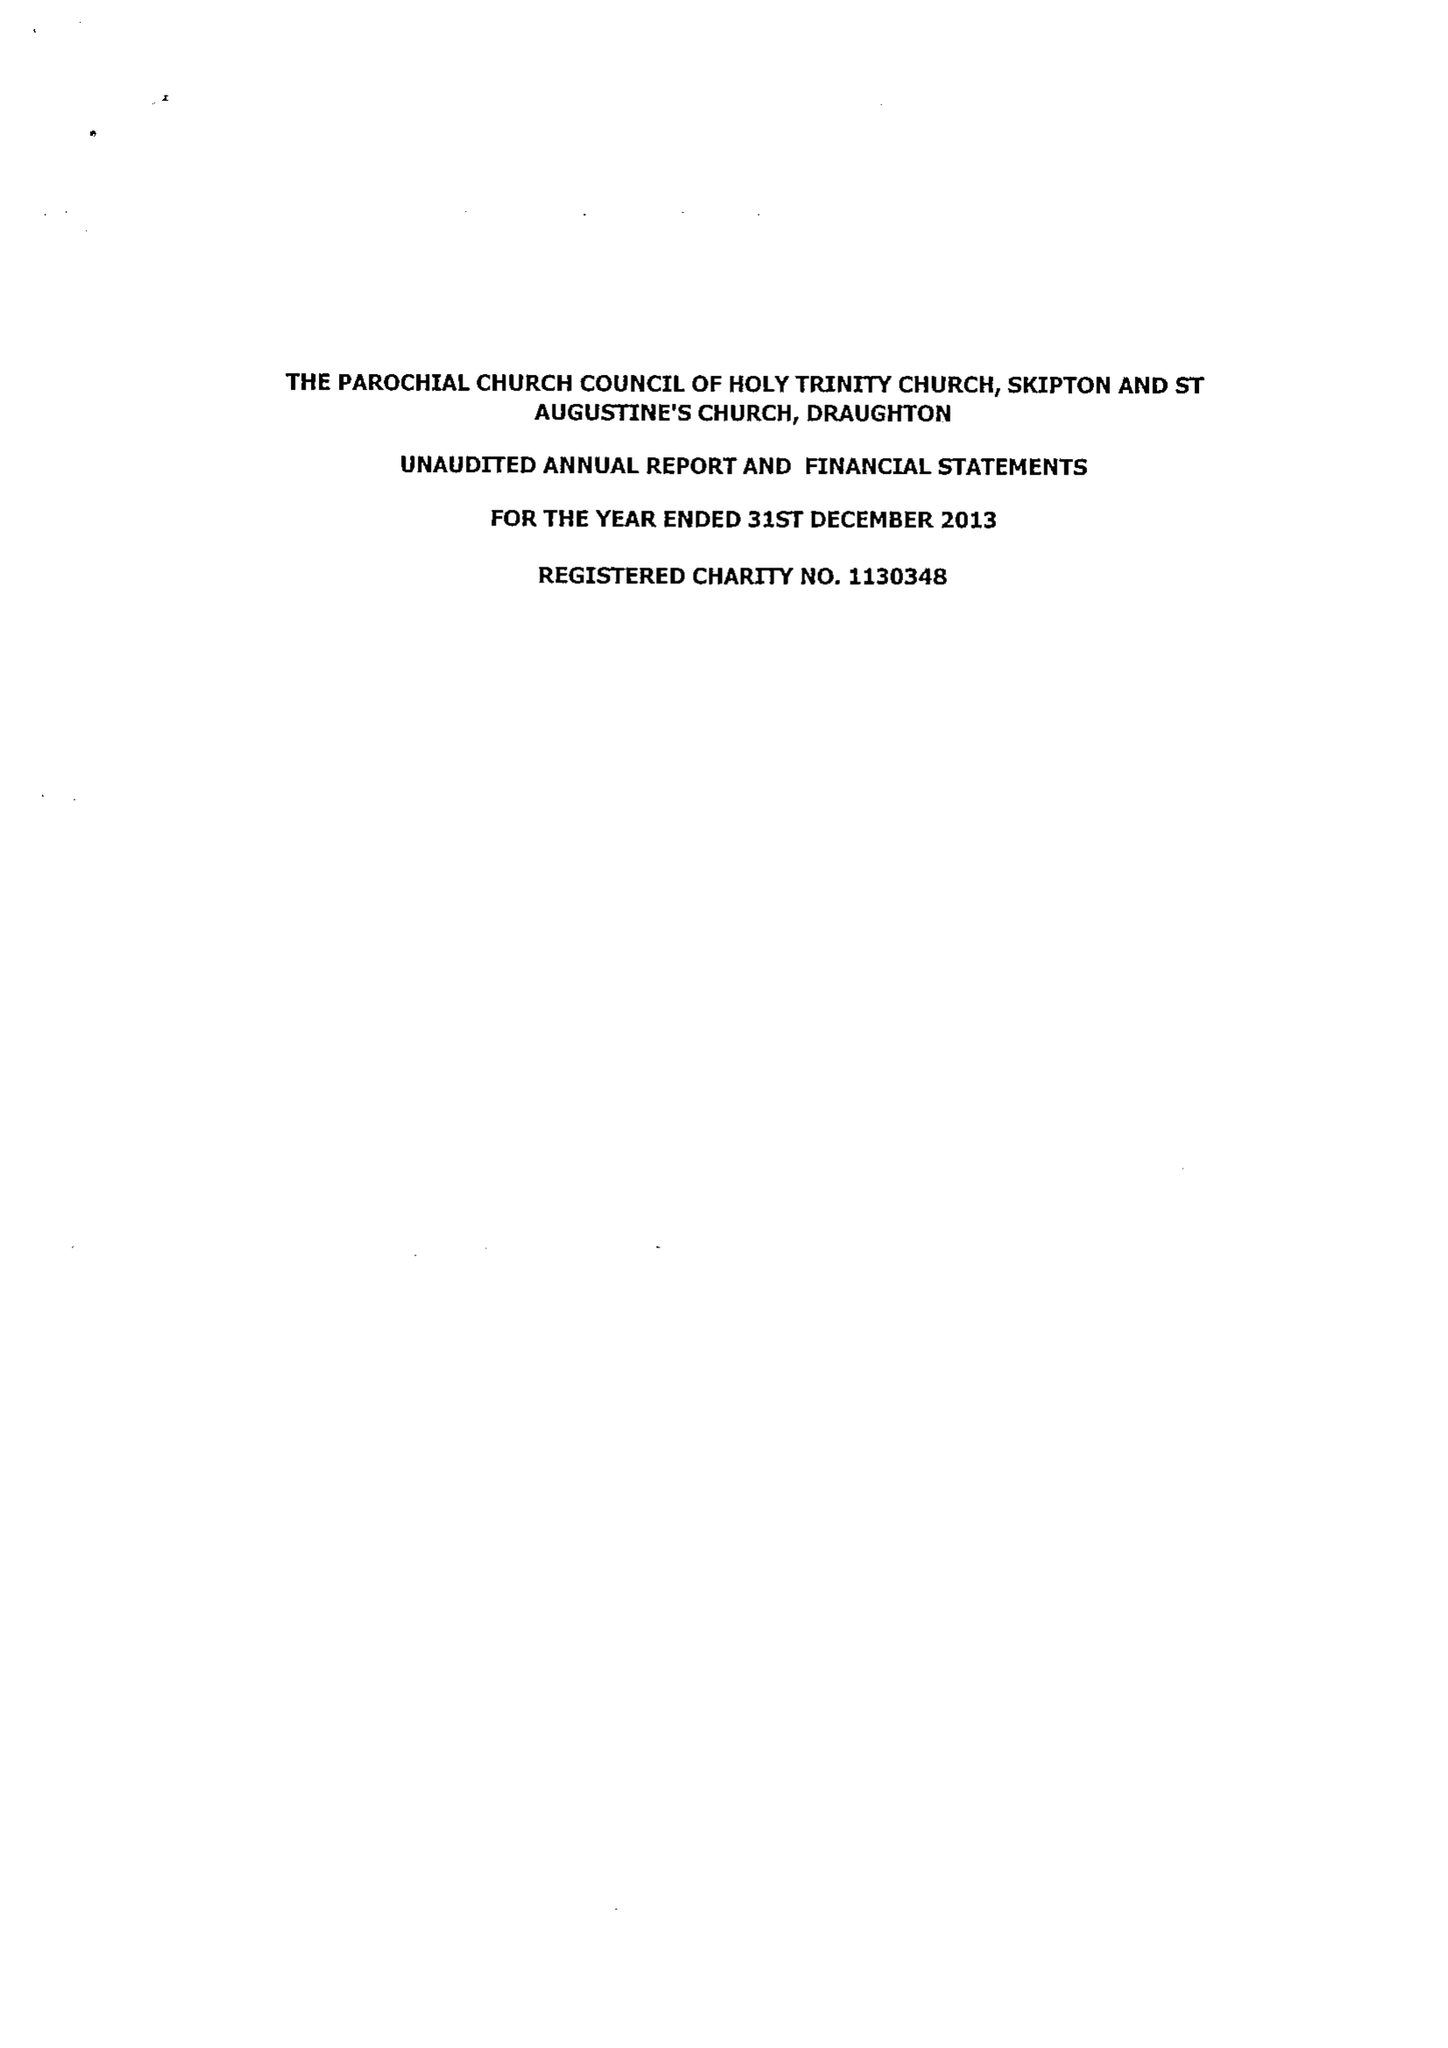What is the value for the charity_name?
Answer the question using a single word or phrase. The Parochial Church Council Of The Ecclesiastical Parish Of Holy Trinity, Skipton 